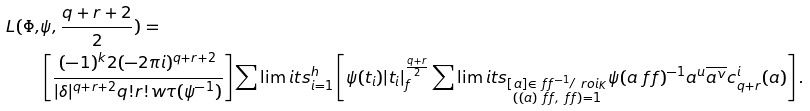<formula> <loc_0><loc_0><loc_500><loc_500>L ( \Phi , & \psi , \frac { q + r + 2 } { 2 } ) = \\ & \left [ \frac { ( - 1 ) ^ { k } 2 ( - 2 \pi i ) ^ { q + r + 2 } } { | \delta | ^ { q + r + 2 } q ! r ! w \tau ( \psi ^ { - 1 } ) } \right ] \sum \lim i t s _ { i = 1 } ^ { h } \left [ \psi ( t _ { i } ) | t _ { i } | _ { f } ^ { \frac { q + r } { 2 } } \sum \lim i t s _ { \substack { [ a ] \in \ f f ^ { - 1 } / \ r o i _ { K } \\ ( ( a ) \ f f , \ f f ) = 1 } } \psi ( a \ f f ) ^ { - 1 } a ^ { u } \overline { a ^ { v } } c _ { q + r } ^ { i } ( a ) \right ] .</formula> 